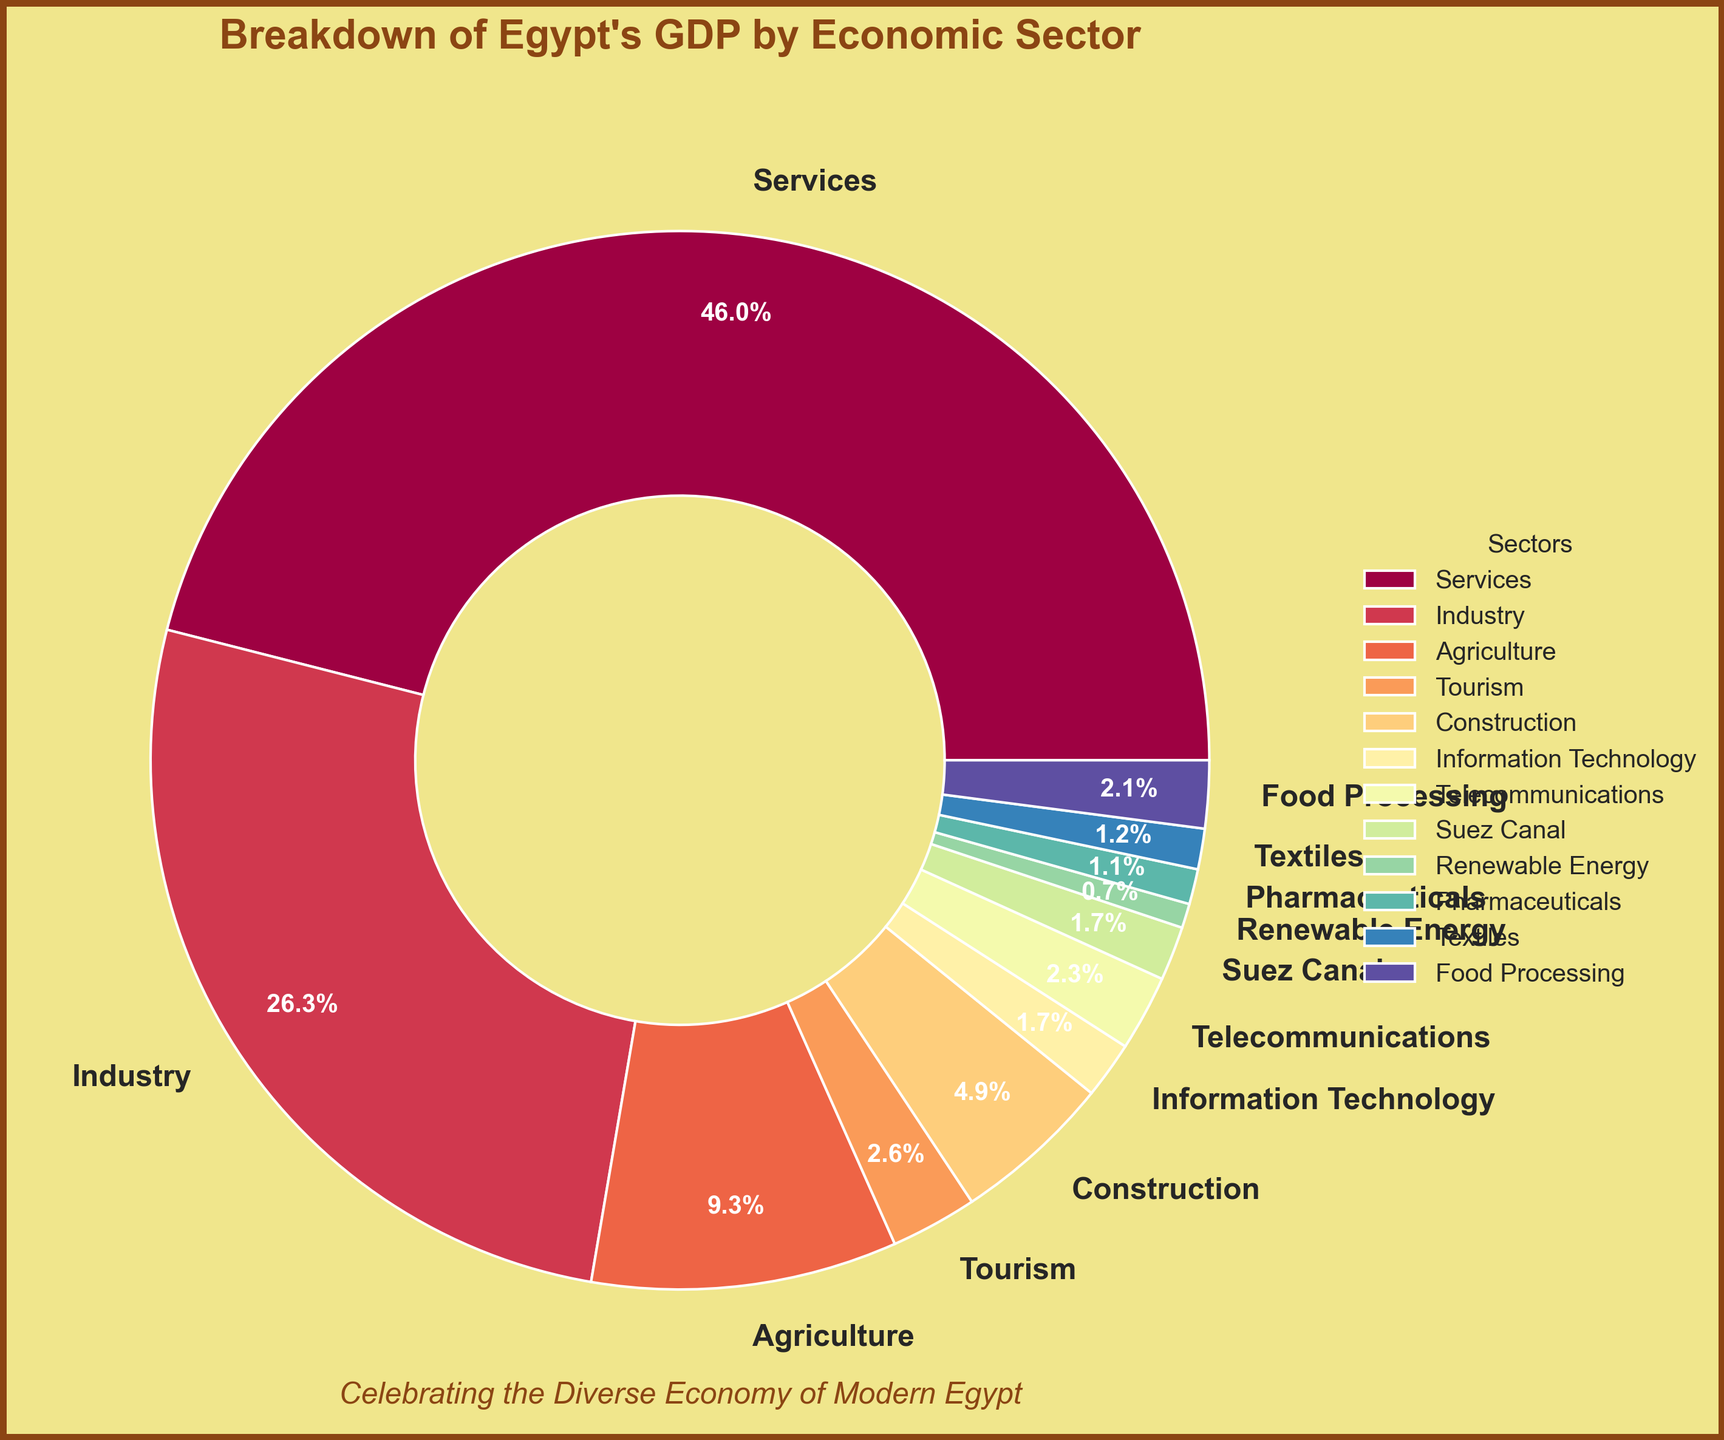What percentage of Egypt's GDP is contributed by sectors other than Services? To find the percentage of GDP contributed by sectors other than Services, subtract the Services percentage from 100%. The percentage for Services is 55.7%, so the rest is 100% - 55.7%.
Answer: 44.3% Which sector contributes more to Egypt's GDP: Industry or Agriculture? Compare the percentages for Industry and Agriculture. Industry contributes 31.8% while Agriculture contributes 11.3%. Therefore, Industry contributes more.
Answer: Industry What is the combined percentage of Egypt's GDP from Agriculture, Construction, and Food Processing? Add the percentages of Agriculture (11.3%), Construction (5.9%), and Food Processing (2.5%) together to get the combined percentage. 11.3% + 5.9% + 2.5% = 19.7%.
Answer: 19.7% How much greater is the contribution of the Services sector compared to the Information Technology and Telecommunications sectors combined? First, add the percentages of Information Technology (2.1%) and Telecommunications (2.8%). Then subtract this sum from the Services sector percentage. 55.7% - (2.1% + 2.8%) = 55.7% - 4.9% = 50.8%
Answer: 50.8% Which sector has the smallest contribution to Egypt's GDP, and what is its percentage? Identify the sector with the lowest percentage in the data. Renewable Energy has the smallest contribution at 0.9%.
Answer: Renewable Energy, 0.9% Is the contribution from the Tourism sector greater than 3%, and if so, by how much? The percentage contribution of Tourism is 3.2%. Subtract 3% from 3.2% to find the difference. 3.2% - 3% = 0.2%.
Answer: Yes, by 0.2% What percentage of Egypt's GDP comes from the Suez Canal and Pharmaceuticals combined? Add the percentages of the Suez Canal (2.0%) and Pharmaceuticals (1.3%) together. 2.0% + 1.3% = 3.3%.
Answer: 3.3% How does the contribution of the Food Processing sector compare with that of the Textiles sector? Compare the percentages of Food Processing (2.5%) and Textiles (1.5%). Food Processing contributes more.
Answer: Food Processing contributes more Which sector has a higher contribution: Telecommunications or Pharmaceuticals, and by how much? Compare the percentages of Telecommunications (2.8%) and Pharmaceuticals (1.3%), then subtract the smaller percentage from the larger one. 2.8% - 1.3% = 1.5%.
Answer: Telecommunications, by 1.5% What is the total percentage of GDP contributed by all sectors listed excluding Tourism? First, sum up all the percentages and then subtract the Tourism percentage. The total is 55.7% + 31.8% + 11.3% + 5.9% + 2.1% + 2.8% + 2.0% + 0.9% + 1.3% + 1.5% + 2.5% = 117.8%. Now subtract the Tourism percentage: 117.8% - 3.2% = 114.6%.
Answer: 114.6% 